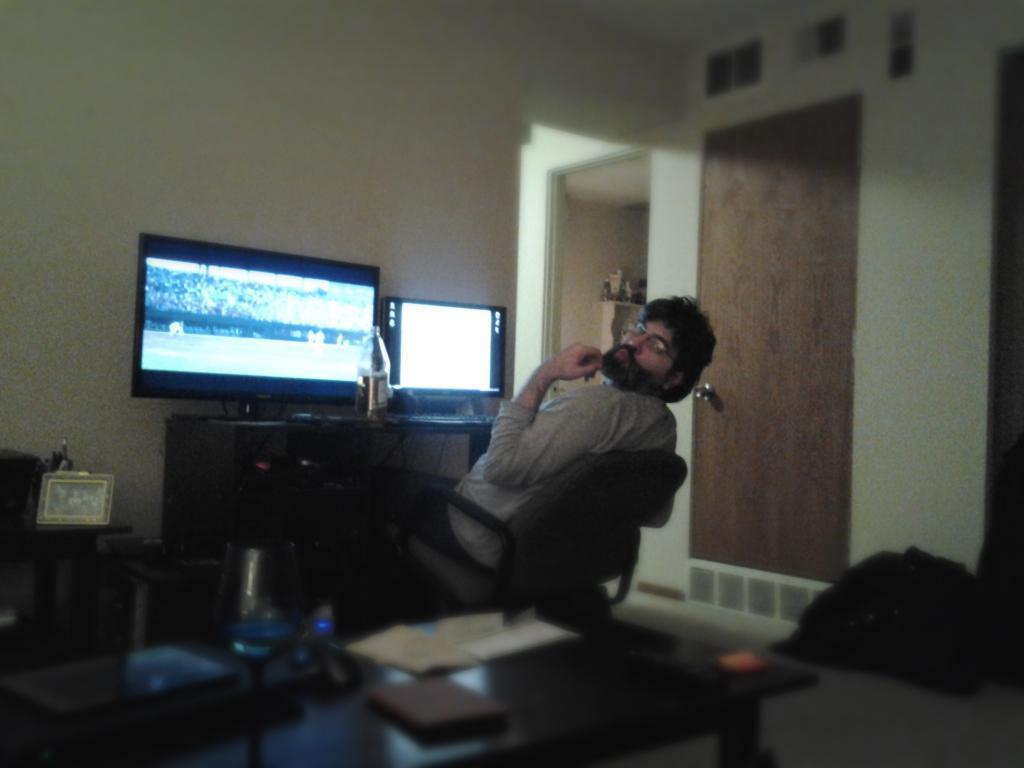Could you give a brief overview of what you see in this image? In this picture there is a person sitting in chair and there is a table in front of him which has a television,desktop and a bottle on it and there is a table in the left corner which has some objects on it and there is a door and some other objects beside him. 